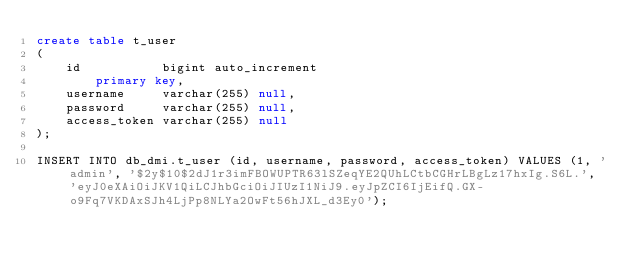Convert code to text. <code><loc_0><loc_0><loc_500><loc_500><_SQL_>create table t_user
(
    id           bigint auto_increment
        primary key,
    username     varchar(255) null,
    password     varchar(255) null,
    access_token varchar(255) null
);

INSERT INTO db_dmi.t_user (id, username, password, access_token) VALUES (1, 'admin', '$2y$10$2dJ1r3imFBOWUPTR63lSZeqYE2QUhLCtbCGHrLBgLz17hxIg.S6L.', 'eyJ0eXAiOiJKV1QiLCJhbGciOiJIUzI1NiJ9.eyJpZCI6IjEifQ.GX-o9Fq7VKDAxSJh4LjPp8NLYa2OwFt56hJXL_d3Ey0');</code> 